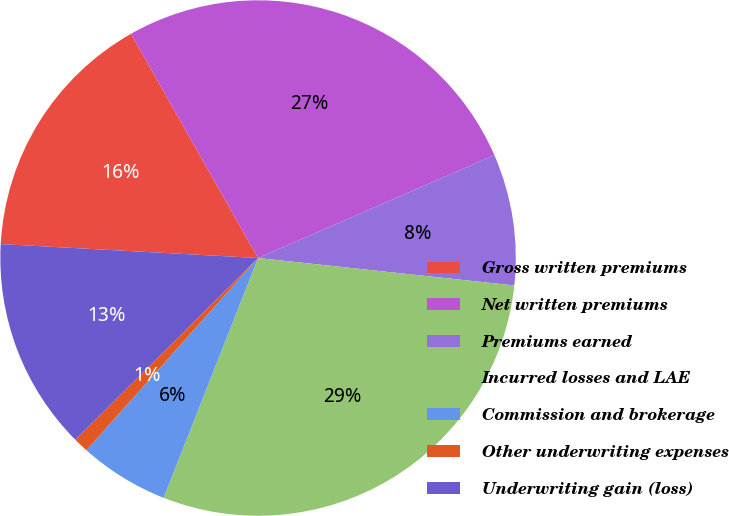<chart> <loc_0><loc_0><loc_500><loc_500><pie_chart><fcel>Gross written premiums<fcel>Net written premiums<fcel>Premiums earned<fcel>Incurred losses and LAE<fcel>Commission and brokerage<fcel>Other underwriting expenses<fcel>Underwriting gain (loss)<nl><fcel>15.93%<fcel>26.67%<fcel>8.23%<fcel>29.27%<fcel>5.63%<fcel>0.94%<fcel>13.32%<nl></chart> 